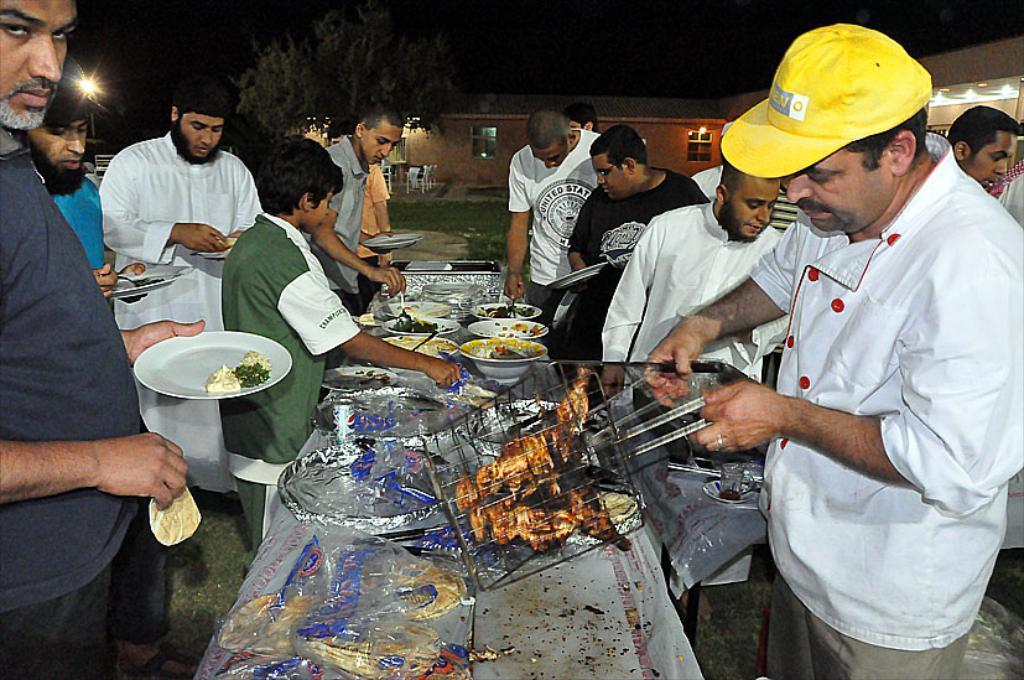Could you give a brief overview of what you see in this image? In this image, we can see persons wearing clothes and standing in front of the table. This table contains plates and bowls. There are some persons holding plates with their hands. There is a person on the right side of the image holding an object with his hands. There is a shelter house and tree at the top of the image. 